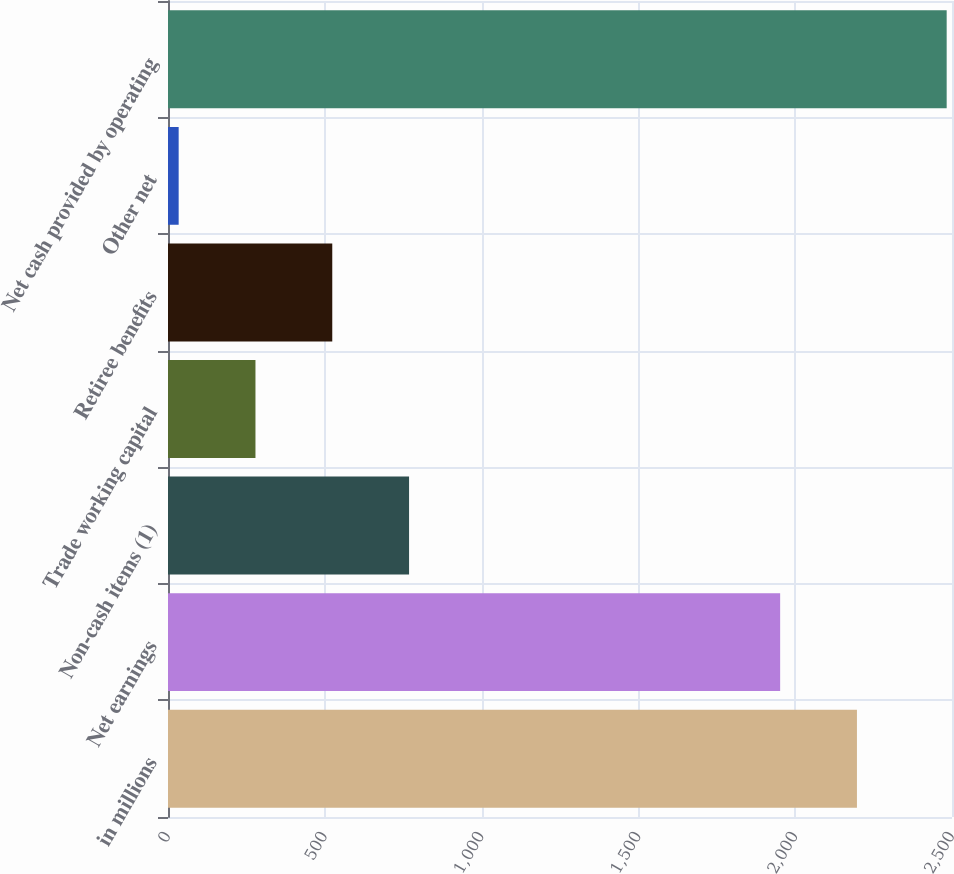<chart> <loc_0><loc_0><loc_500><loc_500><bar_chart><fcel>in millions<fcel>Net earnings<fcel>Non-cash items (1)<fcel>Trade working capital<fcel>Retiree benefits<fcel>Other net<fcel>Net cash provided by operating<nl><fcel>2196.9<fcel>1952<fcel>768.7<fcel>278.9<fcel>523.8<fcel>34<fcel>2483<nl></chart> 